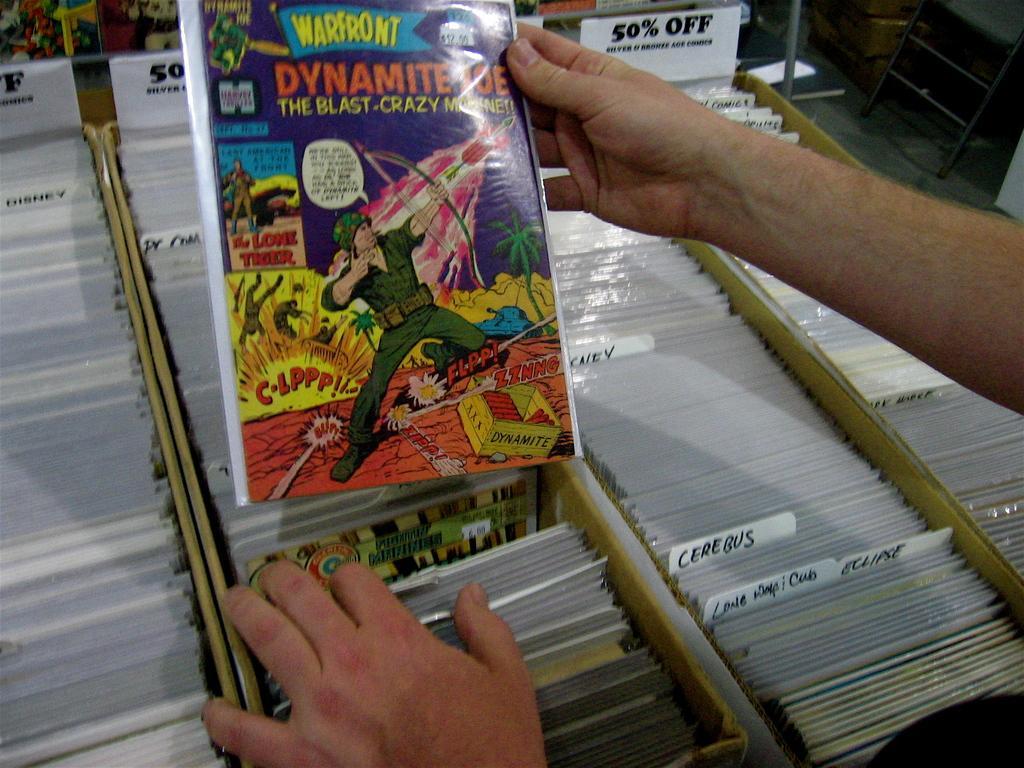Can you describe this image briefly? In this image there is a person holding a cartoon story label in his hand and there are many other labels on the shelf. 